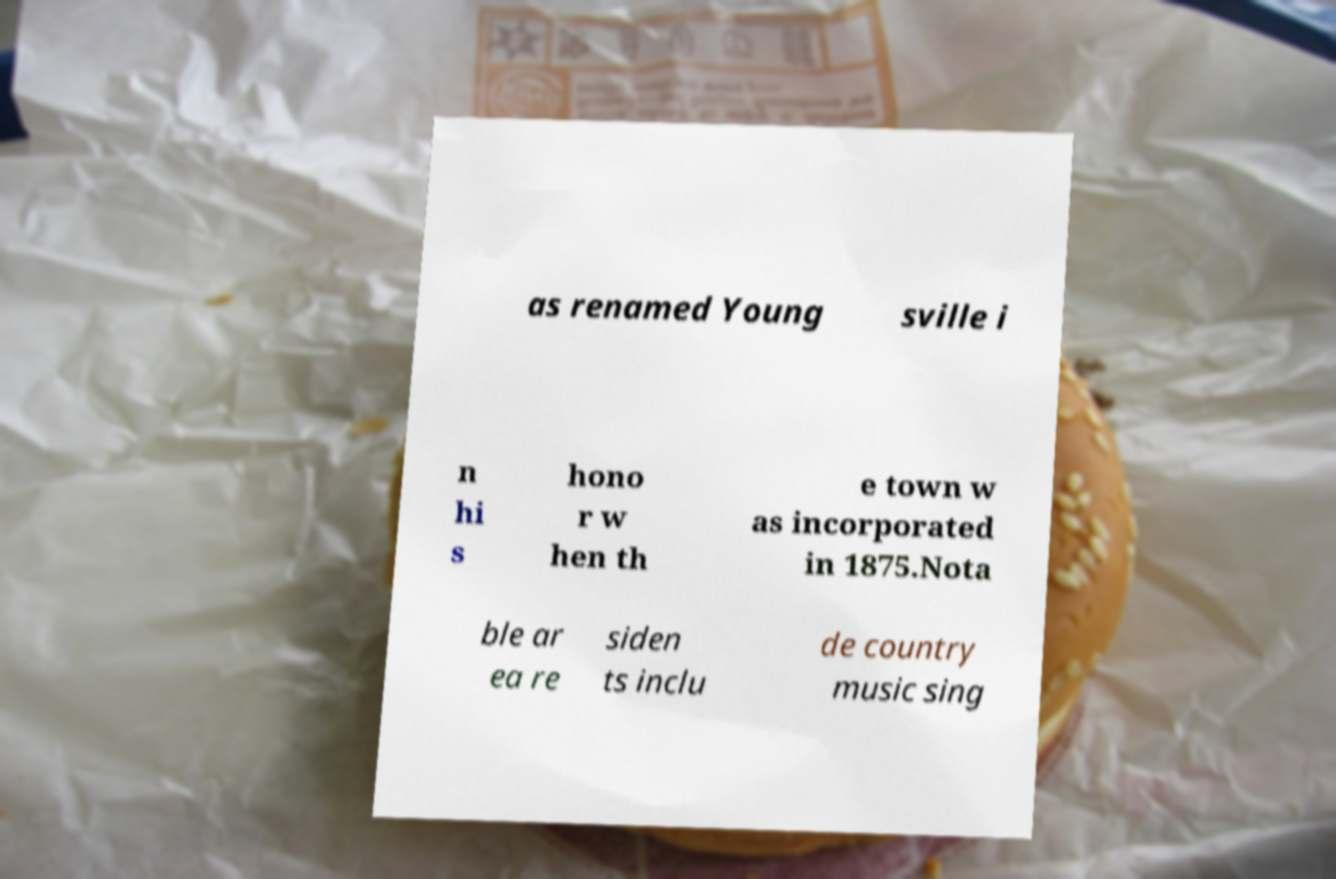Could you assist in decoding the text presented in this image and type it out clearly? as renamed Young sville i n hi s hono r w hen th e town w as incorporated in 1875.Nota ble ar ea re siden ts inclu de country music sing 